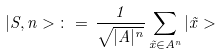Convert formula to latex. <formula><loc_0><loc_0><loc_500><loc_500>| S , n > \, \colon = \, \frac { 1 } { \sqrt { | A | ^ { n } } } \sum _ { \vec { x } \in A ^ { n } } | \vec { x } ></formula> 